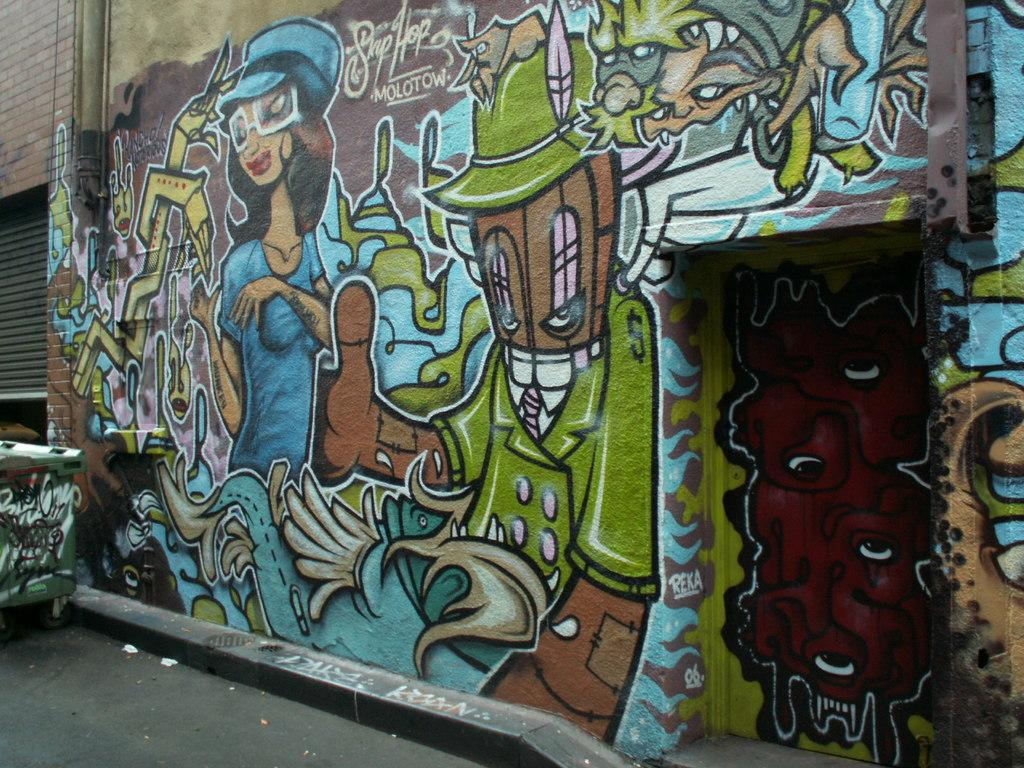What is depicted on the wall in the image? There is a wall with graffiti in the image. What object can be seen on the left side of the image? There is a box on the left side of the image, which appears to be a dustbin. What type of surface is visible at the bottom of the image? There is a road visible at the bottom of the image. Can you see a farmer working in the lake in the image? There is no lake or farmer present in the image. What type of air is visible in the image? There is no air visible in the image, as air is an invisible substance. 